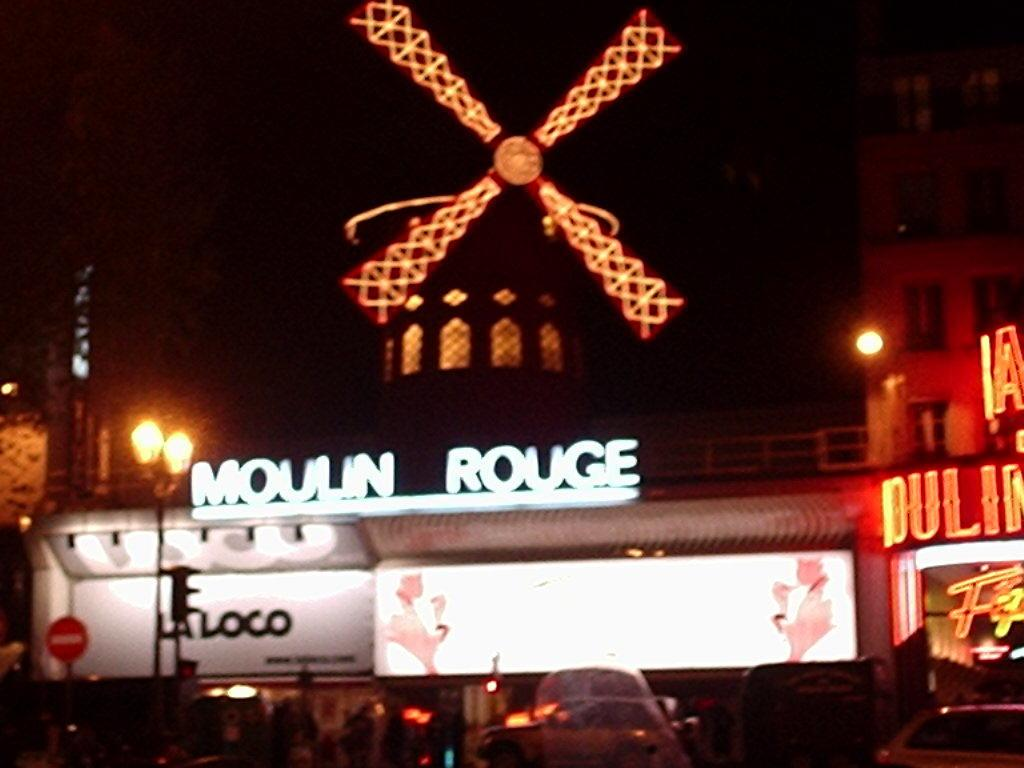What type of structures can be seen in the image? There are buildings in the image. What objects are present that might be used for displaying information or advertisements? There are boards in the image. What can be seen that provides illumination in the image? There are lights in the image. What type of vertical structures are present in the image? There are poles in the image. What type of vehicles can be seen in the image? There are cars in the image. Who is the writer in the image? There is no writer present in the image. What is the size of the judge in the image? There is no judge present in the image, so it is not possible to determine the size of a judge. 